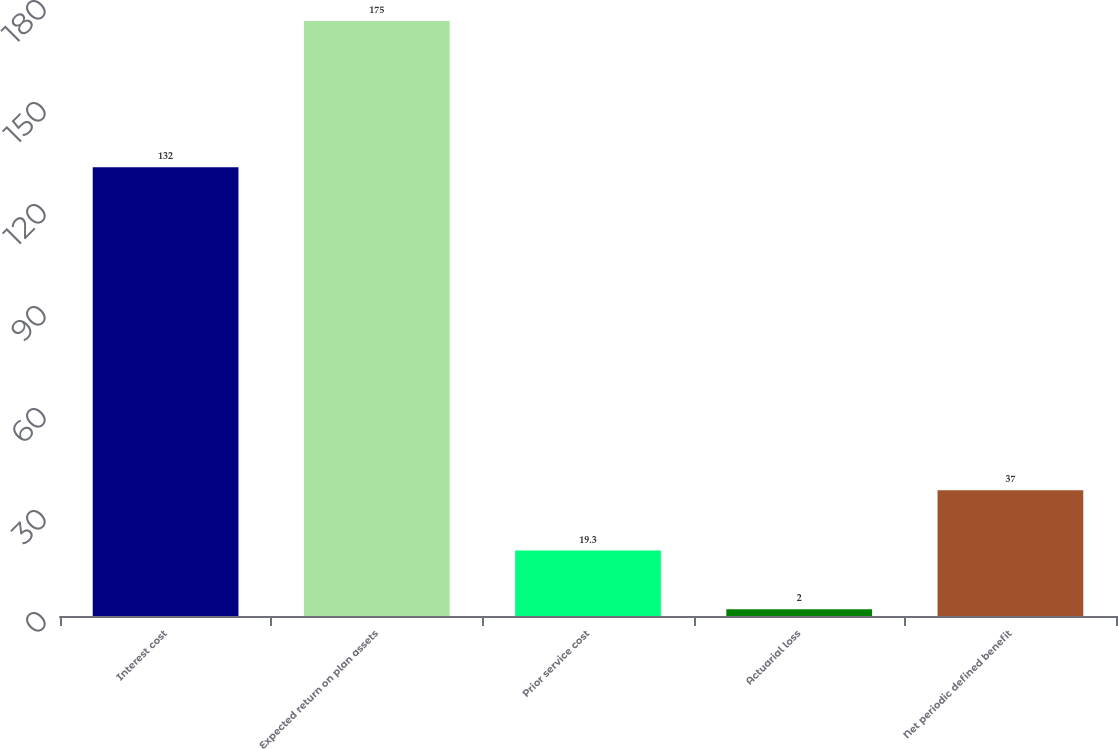Convert chart to OTSL. <chart><loc_0><loc_0><loc_500><loc_500><bar_chart><fcel>Interest cost<fcel>Expected return on plan assets<fcel>Prior service cost<fcel>Actuarial loss<fcel>Net periodic defined benefit<nl><fcel>132<fcel>175<fcel>19.3<fcel>2<fcel>37<nl></chart> 